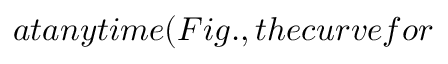Convert formula to latex. <formula><loc_0><loc_0><loc_500><loc_500>a t a n y t i m e ( F i g . , t h e c u r v e f o r</formula> 